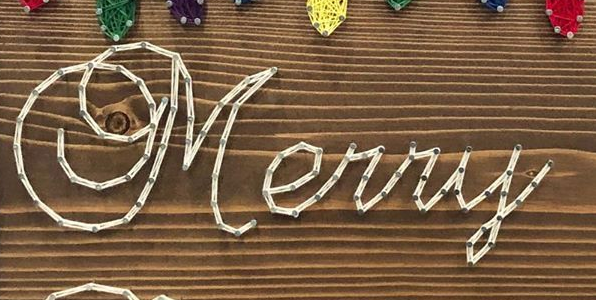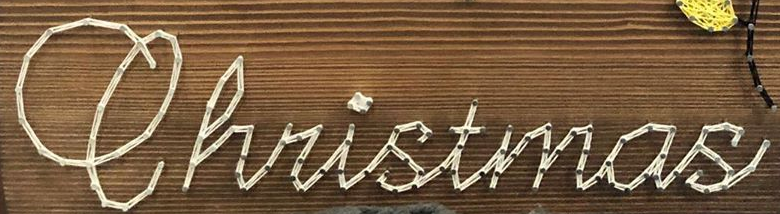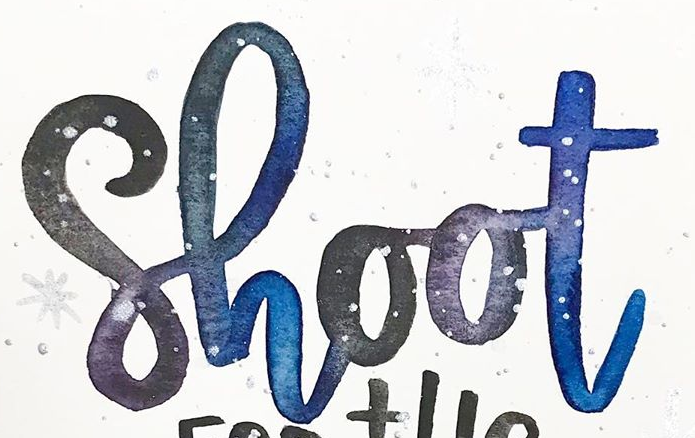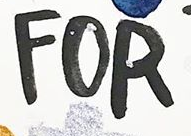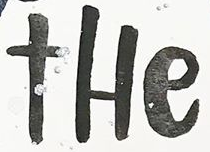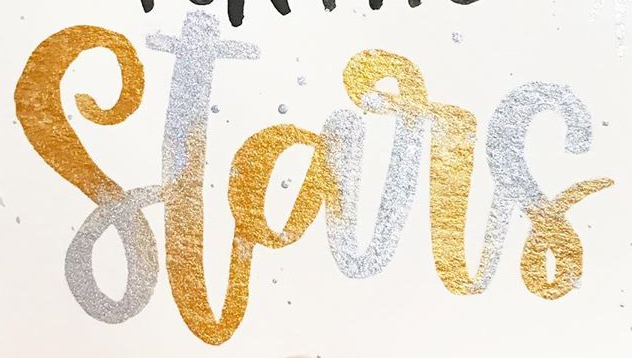Read the text content from these images in order, separated by a semicolon. Merry; Christmas; Shoot; FOR; tHe; Stars 